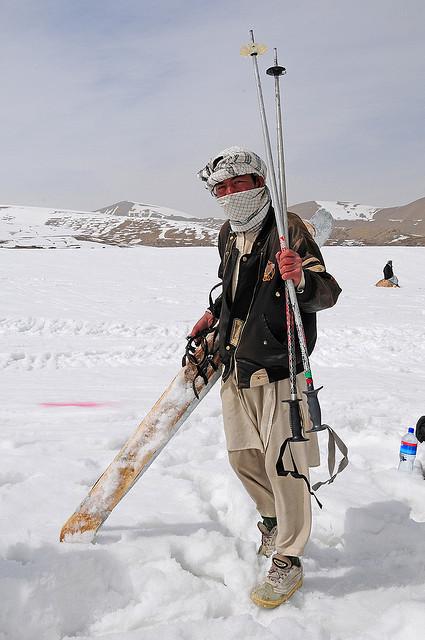Is he in the mountains?
Concise answer only. Yes. What is this person holding in his left hand?
Quick response, please. Ski poles. What is the man holding?
Answer briefly. Ski poles. Is this person cold?
Be succinct. Yes. What color are the skis?
Be succinct. Yellow. What sport is this?
Concise answer only. Skiing. What is the color of the ski poles?
Give a very brief answer. White. What is the man carrying?
Concise answer only. Skis. What is this person wearing on his feet?
Answer briefly. Shoes. 